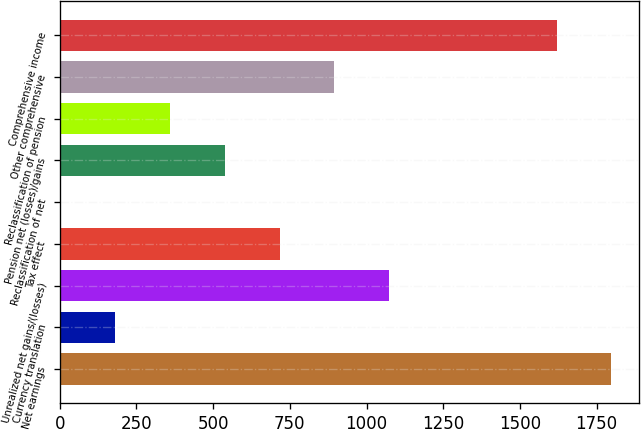<chart> <loc_0><loc_0><loc_500><loc_500><bar_chart><fcel>Net earnings<fcel>Currency translation<fcel>Unrealized net gains/(losses)<fcel>Tax effect<fcel>Reclassification of net<fcel>Pension net (losses)/gains<fcel>Reclassification of pension<fcel>Other comprehensive<fcel>Comprehensive income<nl><fcel>1798.26<fcel>180.76<fcel>1073.56<fcel>716.44<fcel>2.2<fcel>537.88<fcel>359.32<fcel>895<fcel>1619.7<nl></chart> 